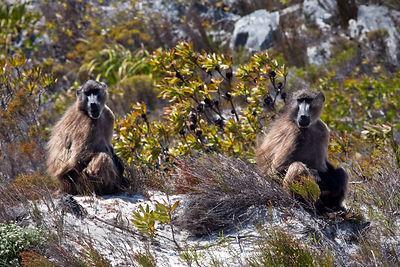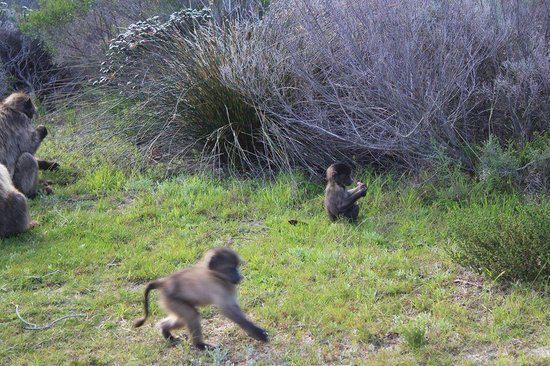The first image is the image on the left, the second image is the image on the right. For the images displayed, is the sentence "At least two animals are huddled together." factually correct? Answer yes or no. No. 